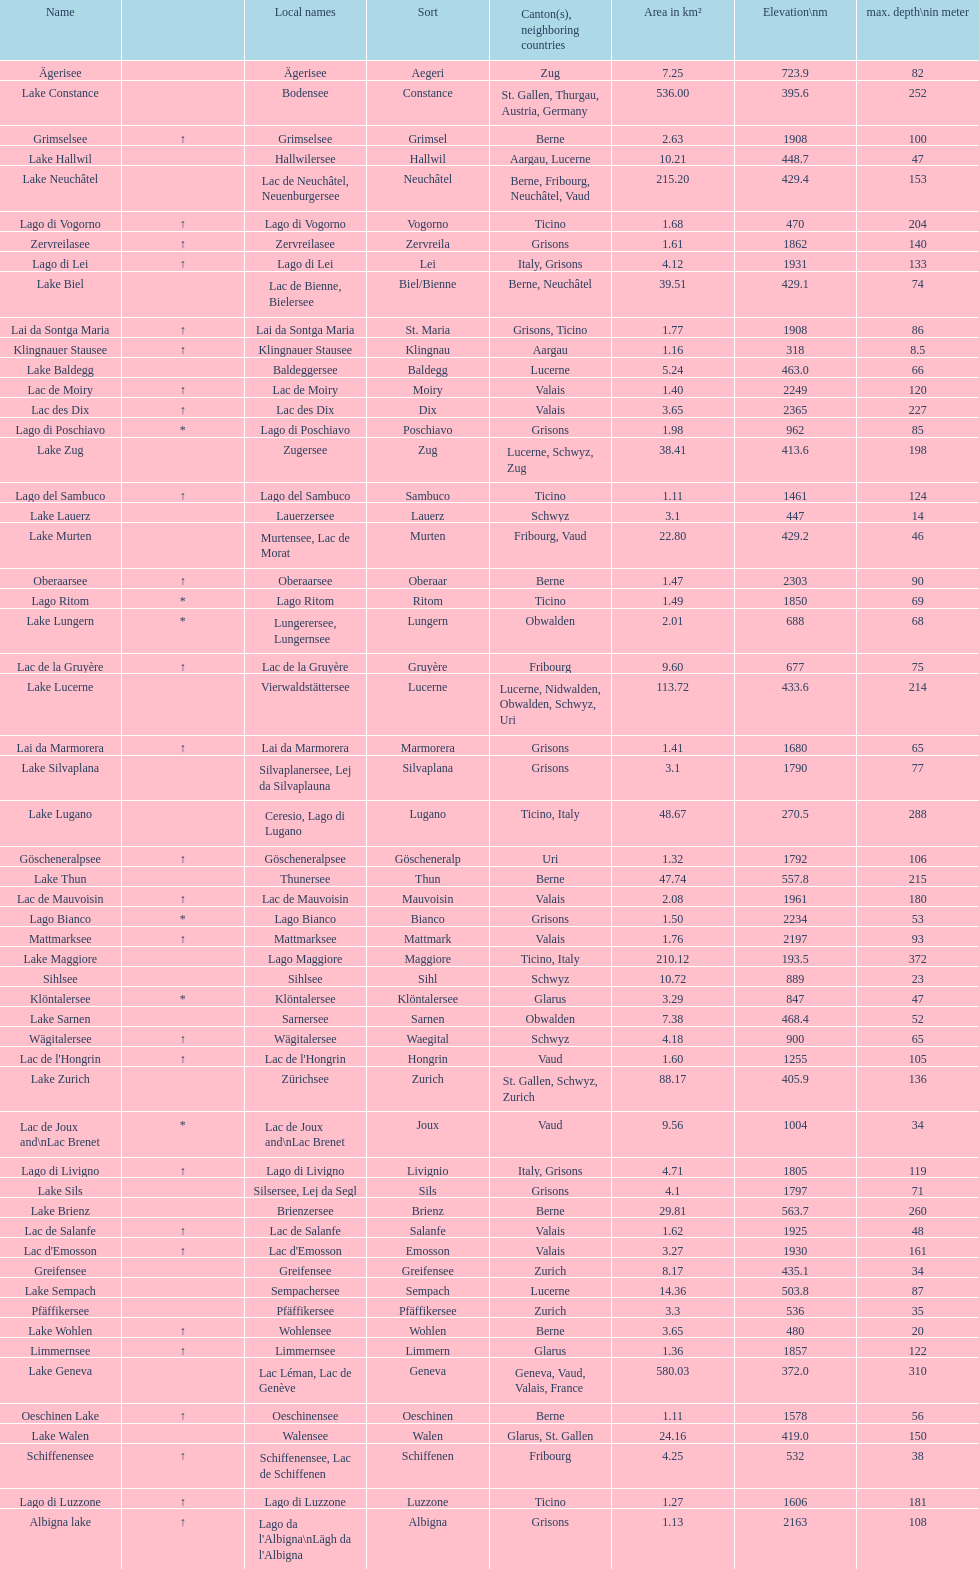Can you parse all the data within this table? {'header': ['Name', '', 'Local names', 'Sort', 'Canton(s), neighboring countries', 'Area in km²', 'Elevation\\nm', 'max. depth\\nin meter'], 'rows': [['Ägerisee', '', 'Ägerisee', 'Aegeri', 'Zug', '7.25', '723.9', '82'], ['Lake Constance', '', 'Bodensee', 'Constance', 'St. Gallen, Thurgau, Austria, Germany', '536.00', '395.6', '252'], ['Grimselsee', '↑', 'Grimselsee', 'Grimsel', 'Berne', '2.63', '1908', '100'], ['Lake Hallwil', '', 'Hallwilersee', 'Hallwil', 'Aargau, Lucerne', '10.21', '448.7', '47'], ['Lake Neuchâtel', '', 'Lac de Neuchâtel, Neuenburgersee', 'Neuchâtel', 'Berne, Fribourg, Neuchâtel, Vaud', '215.20', '429.4', '153'], ['Lago di Vogorno', '↑', 'Lago di Vogorno', 'Vogorno', 'Ticino', '1.68', '470', '204'], ['Zervreilasee', '↑', 'Zervreilasee', 'Zervreila', 'Grisons', '1.61', '1862', '140'], ['Lago di Lei', '↑', 'Lago di Lei', 'Lei', 'Italy, Grisons', '4.12', '1931', '133'], ['Lake Biel', '', 'Lac de Bienne, Bielersee', 'Biel/Bienne', 'Berne, Neuchâtel', '39.51', '429.1', '74'], ['Lai da Sontga Maria', '↑', 'Lai da Sontga Maria', 'St. Maria', 'Grisons, Ticino', '1.77', '1908', '86'], ['Klingnauer Stausee', '↑', 'Klingnauer Stausee', 'Klingnau', 'Aargau', '1.16', '318', '8.5'], ['Lake Baldegg', '', 'Baldeggersee', 'Baldegg', 'Lucerne', '5.24', '463.0', '66'], ['Lac de Moiry', '↑', 'Lac de Moiry', 'Moiry', 'Valais', '1.40', '2249', '120'], ['Lac des Dix', '↑', 'Lac des Dix', 'Dix', 'Valais', '3.65', '2365', '227'], ['Lago di Poschiavo', '*', 'Lago di Poschiavo', 'Poschiavo', 'Grisons', '1.98', '962', '85'], ['Lake Zug', '', 'Zugersee', 'Zug', 'Lucerne, Schwyz, Zug', '38.41', '413.6', '198'], ['Lago del Sambuco', '↑', 'Lago del Sambuco', 'Sambuco', 'Ticino', '1.11', '1461', '124'], ['Lake Lauerz', '', 'Lauerzersee', 'Lauerz', 'Schwyz', '3.1', '447', '14'], ['Lake Murten', '', 'Murtensee, Lac de Morat', 'Murten', 'Fribourg, Vaud', '22.80', '429.2', '46'], ['Oberaarsee', '↑', 'Oberaarsee', 'Oberaar', 'Berne', '1.47', '2303', '90'], ['Lago Ritom', '*', 'Lago Ritom', 'Ritom', 'Ticino', '1.49', '1850', '69'], ['Lake Lungern', '*', 'Lungerersee, Lungernsee', 'Lungern', 'Obwalden', '2.01', '688', '68'], ['Lac de la Gruyère', '↑', 'Lac de la Gruyère', 'Gruyère', 'Fribourg', '9.60', '677', '75'], ['Lake Lucerne', '', 'Vierwaldstättersee', 'Lucerne', 'Lucerne, Nidwalden, Obwalden, Schwyz, Uri', '113.72', '433.6', '214'], ['Lai da Marmorera', '↑', 'Lai da Marmorera', 'Marmorera', 'Grisons', '1.41', '1680', '65'], ['Lake Silvaplana', '', 'Silvaplanersee, Lej da Silvaplauna', 'Silvaplana', 'Grisons', '3.1', '1790', '77'], ['Lake Lugano', '', 'Ceresio, Lago di Lugano', 'Lugano', 'Ticino, Italy', '48.67', '270.5', '288'], ['Göscheneralpsee', '↑', 'Göscheneralpsee', 'Göscheneralp', 'Uri', '1.32', '1792', '106'], ['Lake Thun', '', 'Thunersee', 'Thun', 'Berne', '47.74', '557.8', '215'], ['Lac de Mauvoisin', '↑', 'Lac de Mauvoisin', 'Mauvoisin', 'Valais', '2.08', '1961', '180'], ['Lago Bianco', '*', 'Lago Bianco', 'Bianco', 'Grisons', '1.50', '2234', '53'], ['Mattmarksee', '↑', 'Mattmarksee', 'Mattmark', 'Valais', '1.76', '2197', '93'], ['Lake Maggiore', '', 'Lago Maggiore', 'Maggiore', 'Ticino, Italy', '210.12', '193.5', '372'], ['Sihlsee', '', 'Sihlsee', 'Sihl', 'Schwyz', '10.72', '889', '23'], ['Klöntalersee', '*', 'Klöntalersee', 'Klöntalersee', 'Glarus', '3.29', '847', '47'], ['Lake Sarnen', '', 'Sarnersee', 'Sarnen', 'Obwalden', '7.38', '468.4', '52'], ['Wägitalersee', '↑', 'Wägitalersee', 'Waegital', 'Schwyz', '4.18', '900', '65'], ["Lac de l'Hongrin", '↑', "Lac de l'Hongrin", 'Hongrin', 'Vaud', '1.60', '1255', '105'], ['Lake Zurich', '', 'Zürichsee', 'Zurich', 'St. Gallen, Schwyz, Zurich', '88.17', '405.9', '136'], ['Lac de Joux and\\nLac Brenet', '*', 'Lac de Joux and\\nLac Brenet', 'Joux', 'Vaud', '9.56', '1004', '34'], ['Lago di Livigno', '↑', 'Lago di Livigno', 'Livignio', 'Italy, Grisons', '4.71', '1805', '119'], ['Lake Sils', '', 'Silsersee, Lej da Segl', 'Sils', 'Grisons', '4.1', '1797', '71'], ['Lake Brienz', '', 'Brienzersee', 'Brienz', 'Berne', '29.81', '563.7', '260'], ['Lac de Salanfe', '↑', 'Lac de Salanfe', 'Salanfe', 'Valais', '1.62', '1925', '48'], ["Lac d'Emosson", '↑', "Lac d'Emosson", 'Emosson', 'Valais', '3.27', '1930', '161'], ['Greifensee', '', 'Greifensee', 'Greifensee', 'Zurich', '8.17', '435.1', '34'], ['Lake Sempach', '', 'Sempachersee', 'Sempach', 'Lucerne', '14.36', '503.8', '87'], ['Pfäffikersee', '', 'Pfäffikersee', 'Pfäffikersee', 'Zurich', '3.3', '536', '35'], ['Lake Wohlen', '↑', 'Wohlensee', 'Wohlen', 'Berne', '3.65', '480', '20'], ['Limmernsee', '↑', 'Limmernsee', 'Limmern', 'Glarus', '1.36', '1857', '122'], ['Lake Geneva', '', 'Lac Léman, Lac de Genève', 'Geneva', 'Geneva, Vaud, Valais, France', '580.03', '372.0', '310'], ['Oeschinen Lake', '↑', 'Oeschinensee', 'Oeschinen', 'Berne', '1.11', '1578', '56'], ['Lake Walen', '', 'Walensee', 'Walen', 'Glarus, St. Gallen', '24.16', '419.0', '150'], ['Schiffenensee', '↑', 'Schiffenensee, Lac de Schiffenen', 'Schiffenen', 'Fribourg', '4.25', '532', '38'], ['Lago di Luzzone', '↑', 'Lago di Luzzone', 'Luzzone', 'Ticino', '1.27', '1606', '181'], ['Albigna lake', '↑', "Lago da l'Albigna\\nLägh da l'Albigna", 'Albigna', 'Grisons', '1.13', '2163', '108']]} Which lake is smaller in area km²? albigna lake or oeschinen lake? Oeschinen Lake. 